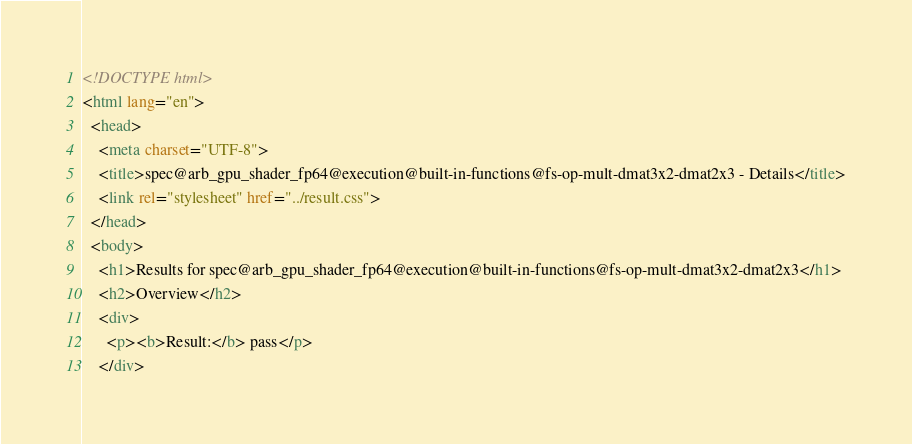<code> <loc_0><loc_0><loc_500><loc_500><_HTML_><!DOCTYPE html>
<html lang="en">
  <head>
    <meta charset="UTF-8">
    <title>spec@arb_gpu_shader_fp64@execution@built-in-functions@fs-op-mult-dmat3x2-dmat2x3 - Details</title>
    <link rel="stylesheet" href="../result.css">
  </head>
  <body>
    <h1>Results for spec@arb_gpu_shader_fp64@execution@built-in-functions@fs-op-mult-dmat3x2-dmat2x3</h1>
    <h2>Overview</h2>
    <div>
      <p><b>Result:</b> pass</p>
    </div></code> 